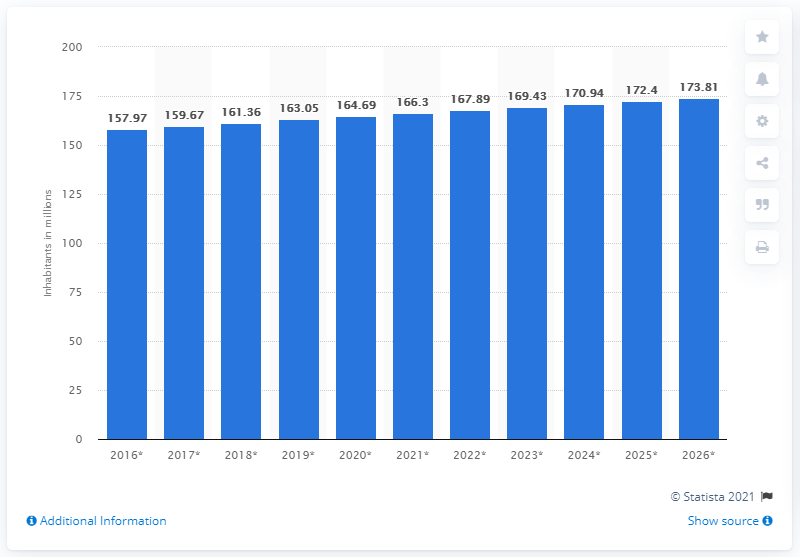Highlight a few significant elements in this photo. In the year 2020, the population of Bangladesh was approximately 166.3 million people. 